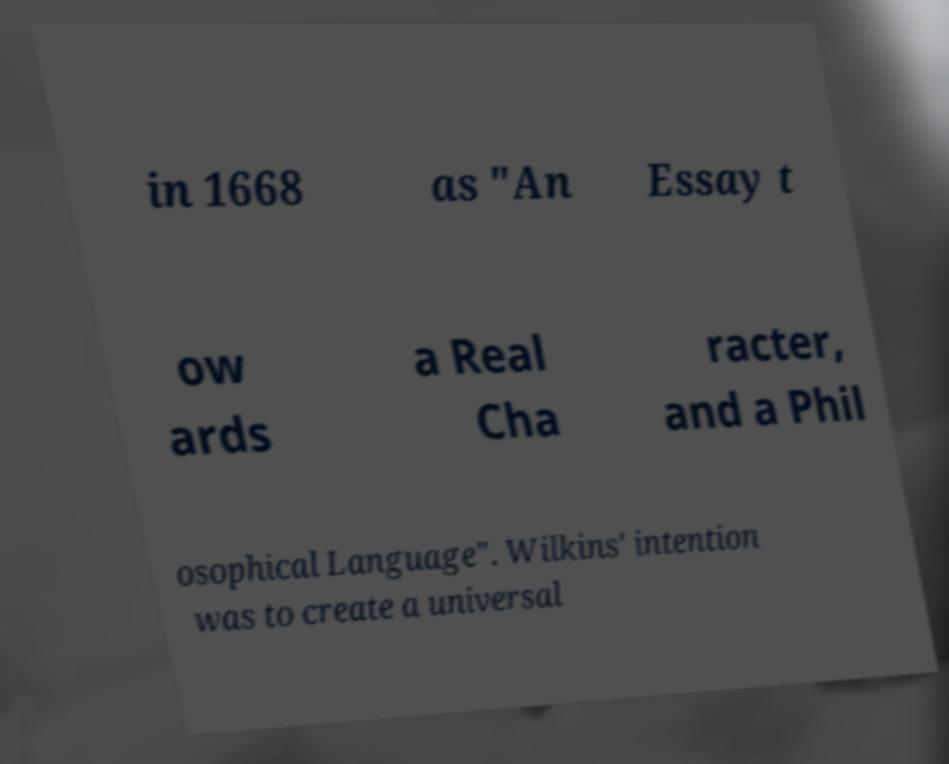Can you accurately transcribe the text from the provided image for me? in 1668 as "An Essay t ow ards a Real Cha racter, and a Phil osophical Language". Wilkins' intention was to create a universal 